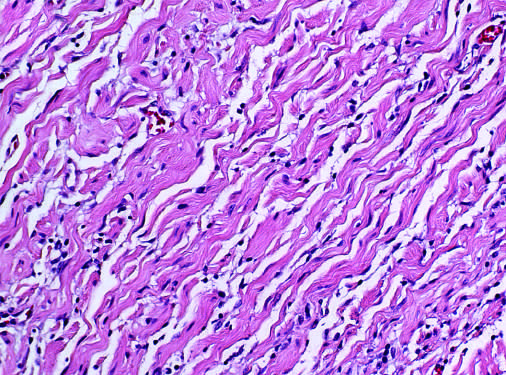re tumor cells seen to consist of bland spindle cells admixed with wavy collagen bundles likened to carrot shavings?
Answer the question using a single word or phrase. Yes 